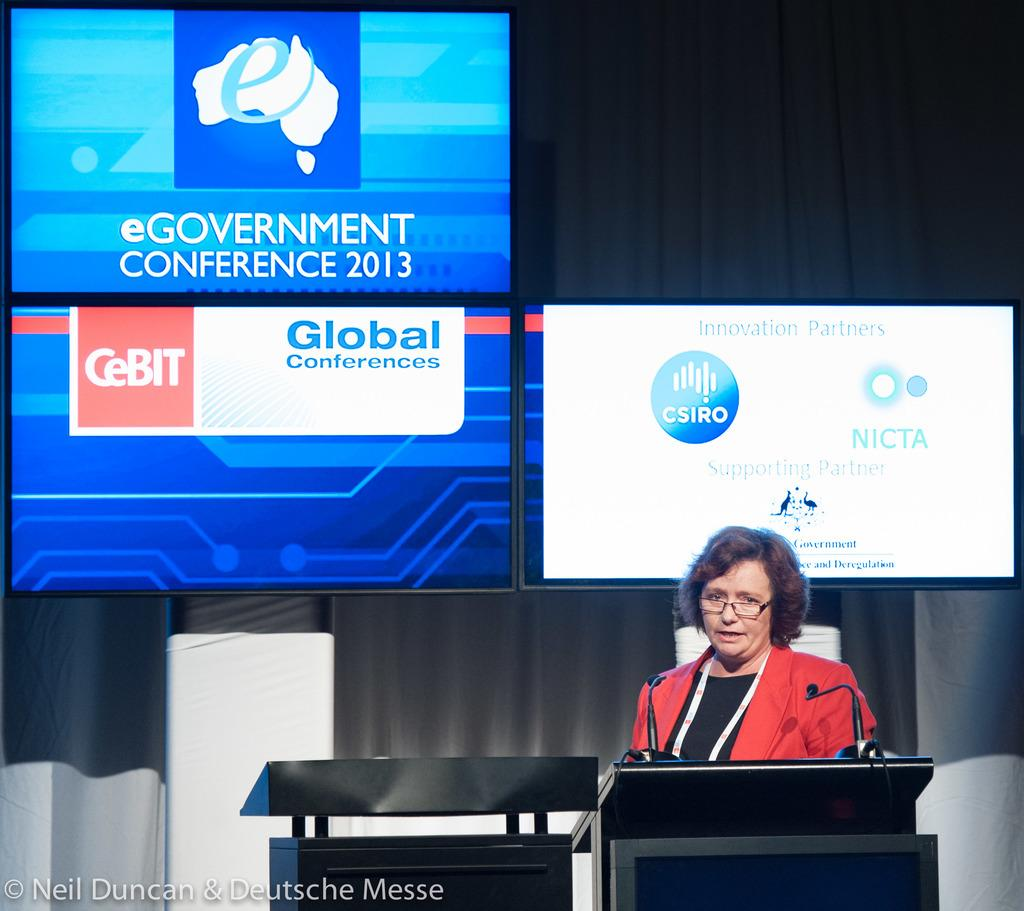<image>
Share a concise interpretation of the image provided. A woman speaks behind a podium at the 2013 eGovernment Conference. 